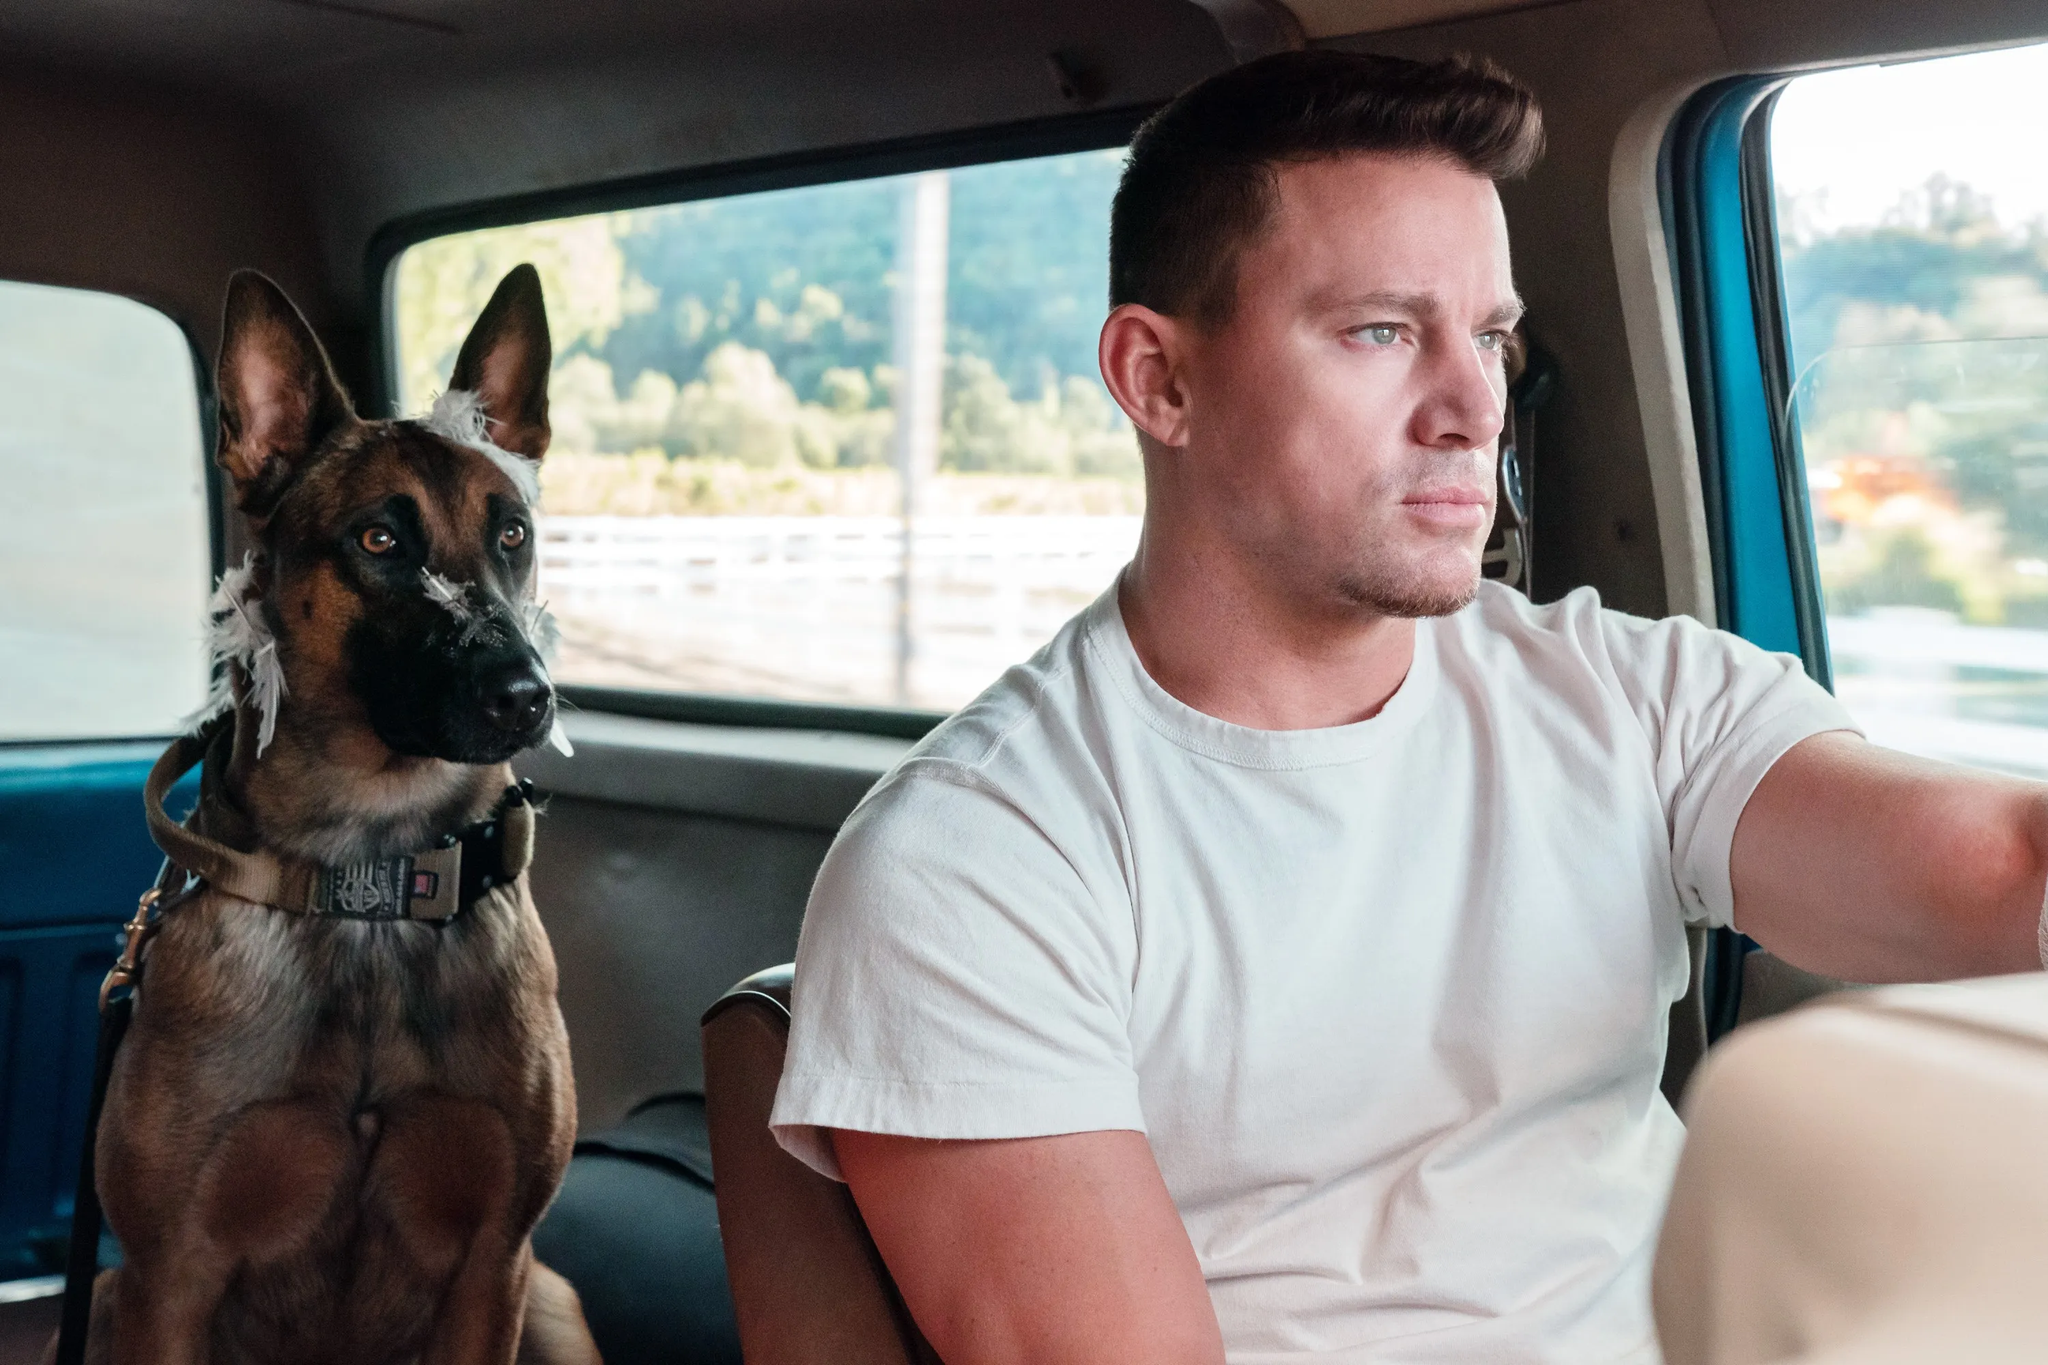What might be going through the mind of the dog in this image? The dog in the image appears to be alert and attentive, likely taking in the sights and sounds around it as they journey together. The road ahead might bring new, exciting experiences, and the dog's focused gaze suggests curiosity and anticipation. It is also possible that the dog feels a deep sense of security and comfort, enjoying the ride and the companionship of its owner. 